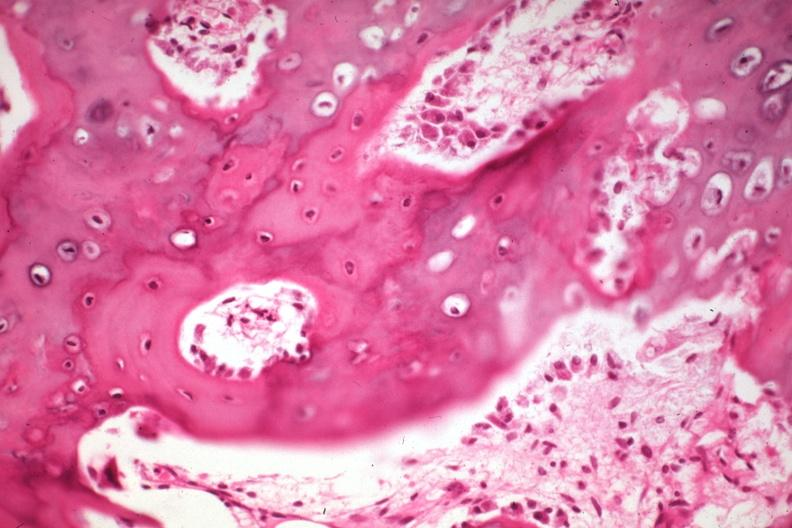what is present?
Answer the question using a single word or phrase. Joints 